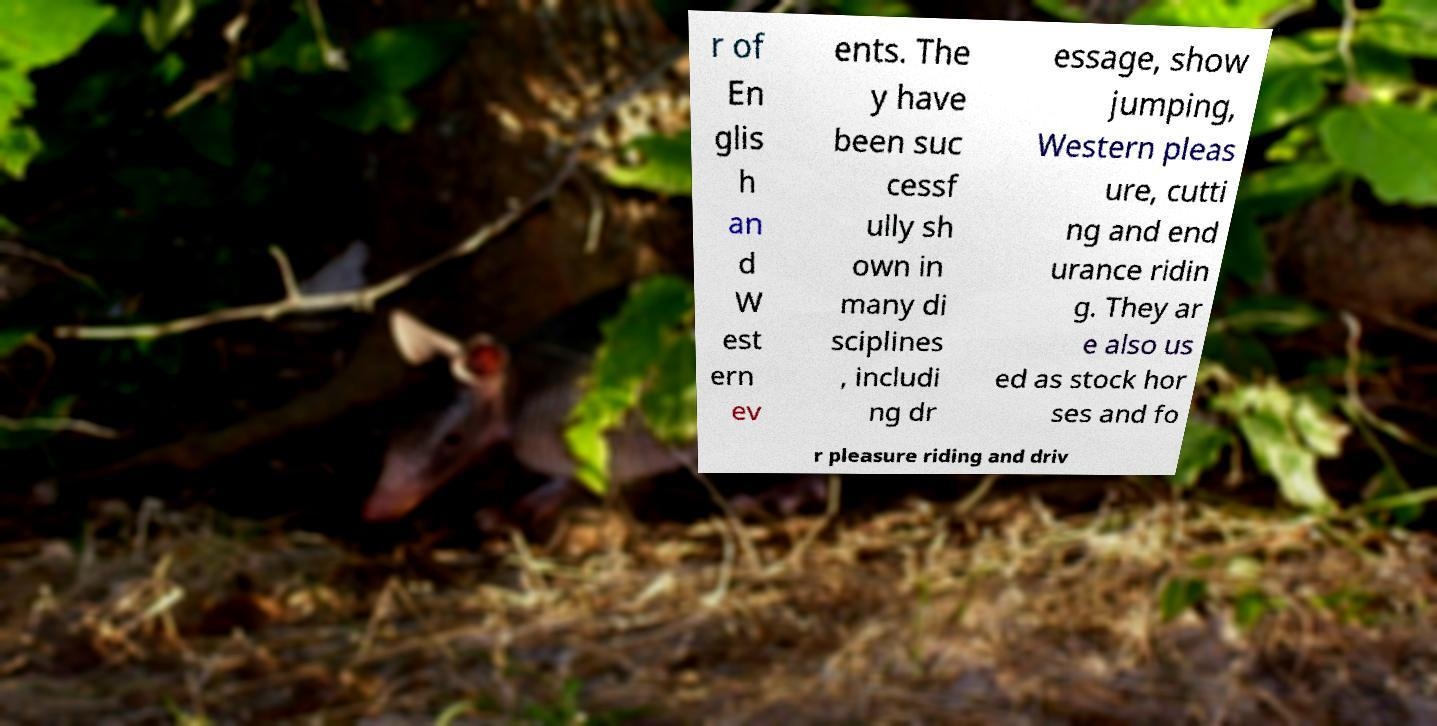Can you read and provide the text displayed in the image?This photo seems to have some interesting text. Can you extract and type it out for me? r of En glis h an d W est ern ev ents. The y have been suc cessf ully sh own in many di sciplines , includi ng dr essage, show jumping, Western pleas ure, cutti ng and end urance ridin g. They ar e also us ed as stock hor ses and fo r pleasure riding and driv 